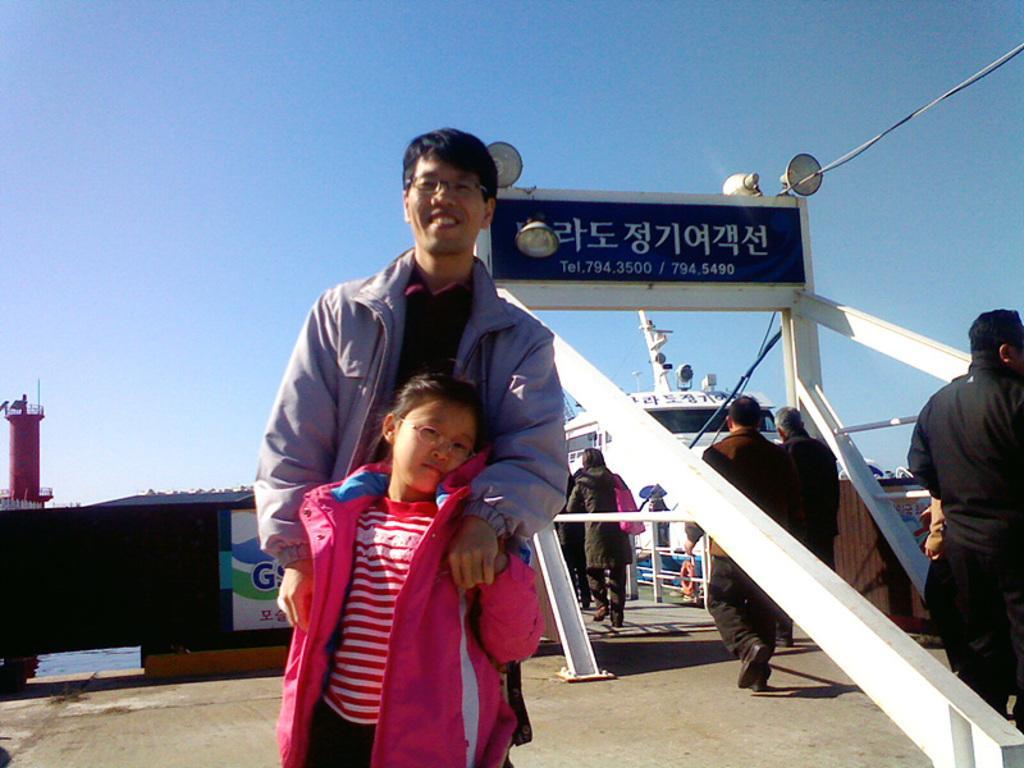Please provide a concise description of this image. This image consists of many people. At the bottom, there is ground. In the background, there is a name board. In the front, the girl is wearing pink jacket. 